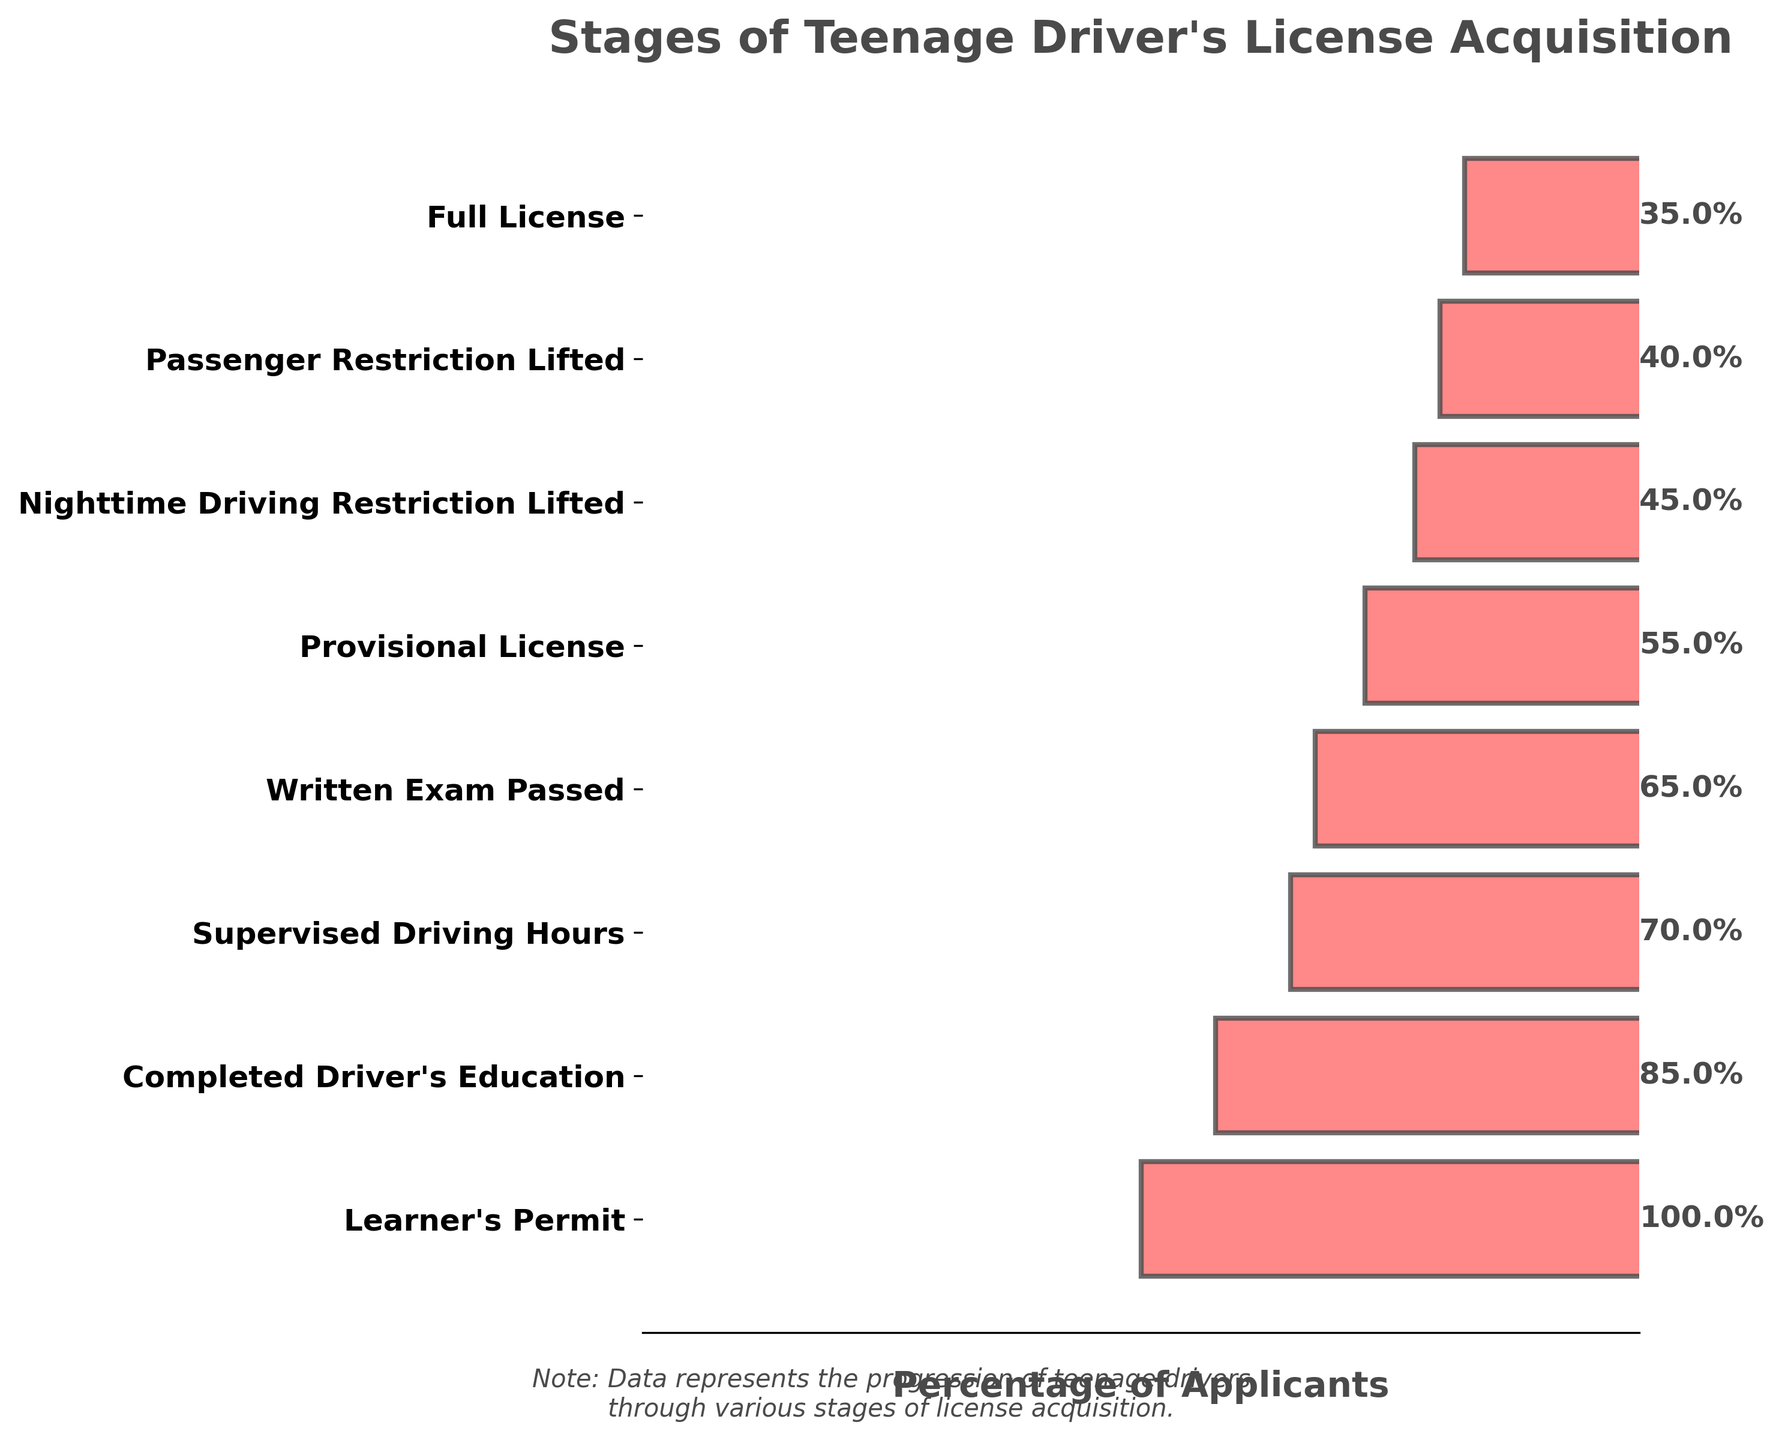What is the title of the figure? The title is typically placed at the top of the plot and is meant to describe the main subject of the chart.
Answer: Stages of Teenage Driver's License Acquisition How many stages are shown in the chart? To determine the number of stages, count the rows or horizontal bars in the funnel chart.
Answer: Eight stages Which stage has the highest percentage of applicants? Identify the bar with the largest width and refer to the corresponding stage label.
Answer: Learner's Permit By how much does the percentage of applicants decrease from the Learner's Permit stage to the Full License stage? Subtract the percentage of the Full License stage from the percentage of the Learner's Permit stage: 100% - 35% = 65%.
Answer: 65% Compare the percentage of applicants at the Completed Driver's Education stage to the Supervised Driving Hours stage. Which is higher and by how much? Look at the percentage for both stages and subtract the smaller percentage from the larger one: 85% - 70% = 15%. Completed Driver's Education is higher by 15%.
Answer: Completed Driver's Education by 15% What is the percentage of applicants who pass the Written Exam after completing Supervised Driving Hours? Find the percentage at the Supervised Driving Hours stage and the percentage at the Written Exam Passed stage, then compare both values: 70% to 65%.
Answer: 65% Which stages have a lower percentage of applicants than the Provisional License stage? Compare the percentage of subsequent stages after the Provisional License stage and identify those with smaller percentages.
Answer: Nighttime Driving Restriction Lifted, Passenger Restriction Lifted, Full License Calculate the average percentage of applicants for the last three stages of acquisition. Add the percentages of the last three stages and divide by 3: (45% + 40% + 35%) / 3 = 40%.
Answer: 40% Is there a stage where the drop in applicants is greater than 20% between successive stages? If yes, which one? Compare the percentages of successive stages and look for a difference greater than 20%. The drop from Learner's Permit to Completed Driver's Education is 15%, from Completed Driver's Education to Supervised Driving Hours is 15%, none of them exceed 20%.
Answer: No What is the drop in percentage from Provisional License to Nighttime Driving Restriction Lifted? Subtract the percentage at the Nighttime Driving Restriction Lifted stage from the Provisional License stage: 55% - 45% = 10%.
Answer: 10% How many stages are there from passing the Written Exam until obtaining the Full License? Count the number of stages between Written Exam Passed and Full License: 1. Provisional License 2. Nighttime Driving Restriction Lifted 3. Passenger Restriction Lifted.
Answer: Three stages 